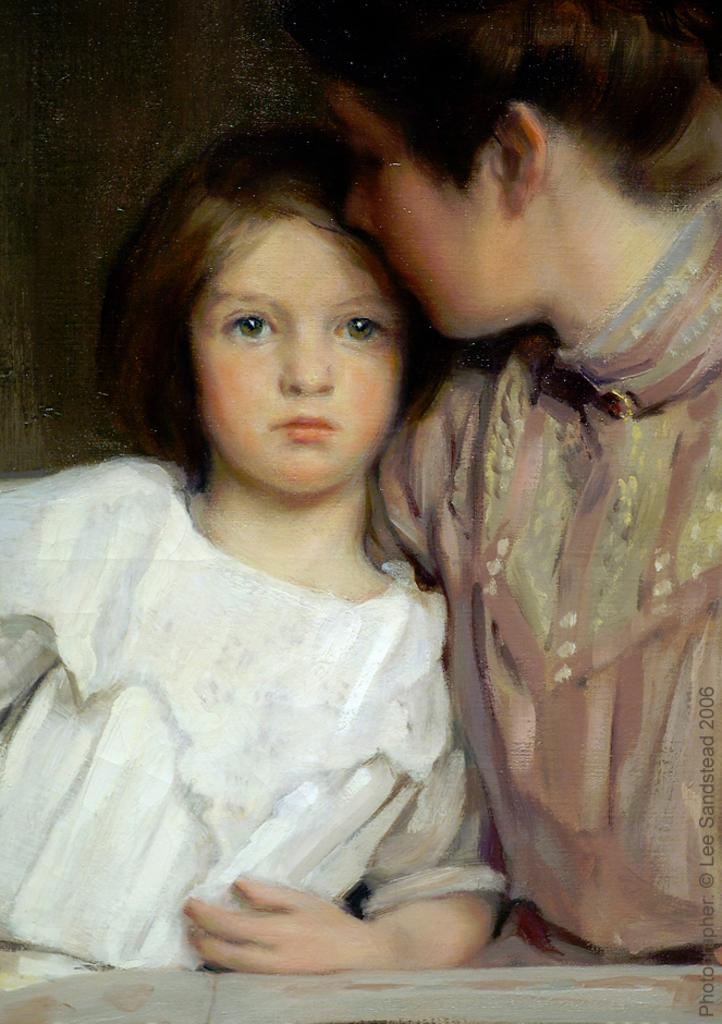How many people are present in the image? There are two people in the image. What action is one person performing on the other person? One person is giving a peck on the other person's forehead. What type of artwork is the image? The image is a painting. What day of the week is depicted on the calendar in the image? There is no calendar present in the image. What advice does the minister give to the couple in the image? There is no minister or couple present in the image; it features two people and their interaction. 